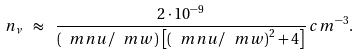Convert formula to latex. <formula><loc_0><loc_0><loc_500><loc_500>n _ { \nu } \ \approx \ \frac { 2 \cdot 1 0 ^ { - 9 } } { \left ( \ m n u / \ m w \right ) \, \left [ \left ( \ m n u / \ m w \right ) ^ { 2 } + 4 \right ] } \, c m ^ { - 3 } .</formula> 